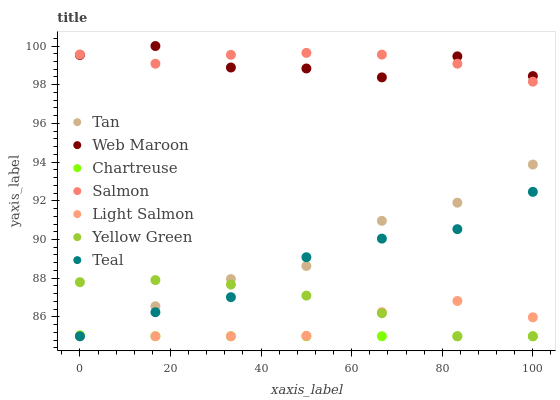Does Chartreuse have the minimum area under the curve?
Answer yes or no. Yes. Does Salmon have the maximum area under the curve?
Answer yes or no. Yes. Does Yellow Green have the minimum area under the curve?
Answer yes or no. No. Does Yellow Green have the maximum area under the curve?
Answer yes or no. No. Is Chartreuse the smoothest?
Answer yes or no. Yes. Is Web Maroon the roughest?
Answer yes or no. Yes. Is Yellow Green the smoothest?
Answer yes or no. No. Is Yellow Green the roughest?
Answer yes or no. No. Does Light Salmon have the lowest value?
Answer yes or no. Yes. Does Web Maroon have the lowest value?
Answer yes or no. No. Does Web Maroon have the highest value?
Answer yes or no. Yes. Does Yellow Green have the highest value?
Answer yes or no. No. Is Yellow Green less than Salmon?
Answer yes or no. Yes. Is Web Maroon greater than Yellow Green?
Answer yes or no. Yes. Does Teal intersect Tan?
Answer yes or no. Yes. Is Teal less than Tan?
Answer yes or no. No. Is Teal greater than Tan?
Answer yes or no. No. Does Yellow Green intersect Salmon?
Answer yes or no. No. 